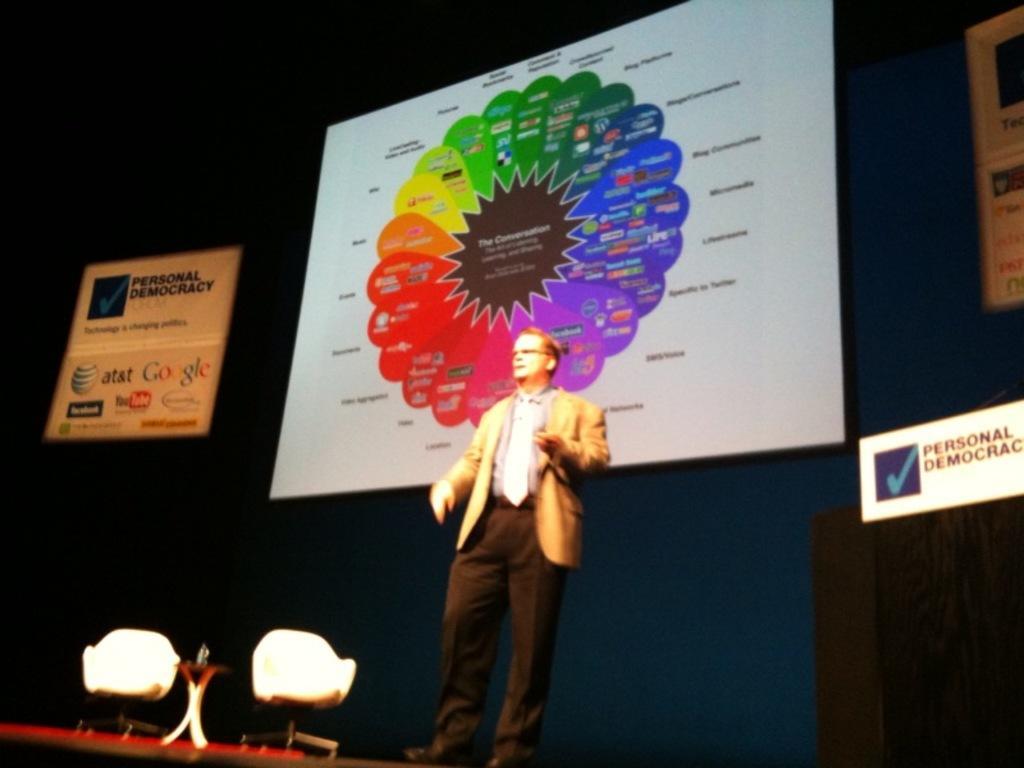How would you summarize this image in a sentence or two? In this image we can see a person standing wearing a suit. There are two chairs. There is a table. In the background of the image there is a screen with some text on it. 